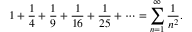<formula> <loc_0><loc_0><loc_500><loc_500>1 + { \frac { 1 } { 4 } } + { \frac { 1 } { 9 } } + { \frac { 1 } { 1 6 } } + { \frac { 1 } { 2 5 } } + \cdots = \sum _ { n = 1 } ^ { \infty } { \frac { 1 } { n ^ { 2 } } } .</formula> 